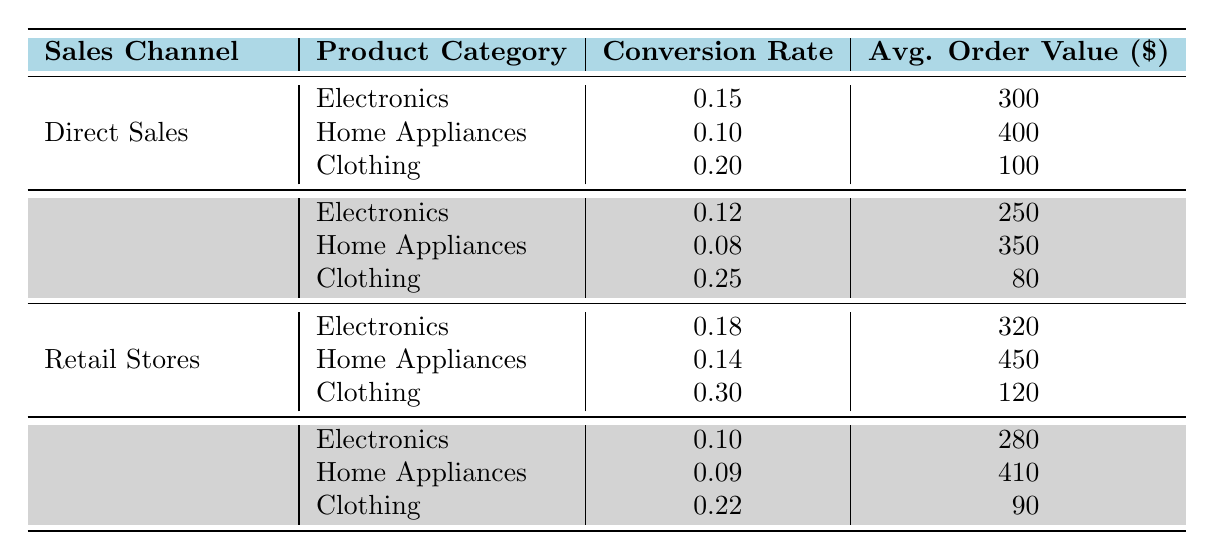What is the conversion rate for Clothing in the Direct Sales channel? Referring to the table, under the "Direct Sales" channel, the entry for "Clothing" shows a conversion rate of 0.20.
Answer: 0.20 Which sales channel has the highest average order value for Home Appliances? Looking at the Home Appliances category, the average order values are: Direct Sales - 400, Online Marketplace - 350, Retail Stores - 450, and Social Media - 410. The highest average order value is from Retail Stores.
Answer: Retail Stores What is the average conversion rate for Electronics across all sales channels? The conversion rates for Electronics are: Direct Sales - 0.15, Online Marketplace - 0.12, Retail Stores - 0.18, and Social Media - 0.10. Adding these values gives 0.15 + 0.12 + 0.18 + 0.10 = 0.55. Dividing by 4 (the number of channels), the average conversion rate is 0.55 / 4 = 0.1375.
Answer: 0.1375 Does the Online Marketplace have a higher conversion rate for Clothing than Direct Sales? Comparing the conversion rates: Online Marketplace for Clothing is 0.25, and Direct Sales for Clothing is 0.20. Since 0.25 is greater than 0.20, the statement is true.
Answer: Yes What is the difference in average order value between Retail Stores and Online Marketplace for Electronics? Looking at the average order values: Retail Stores for Electronics is 320 and Online Marketplace is 250. The difference is 320 - 250 = 70.
Answer: 70 